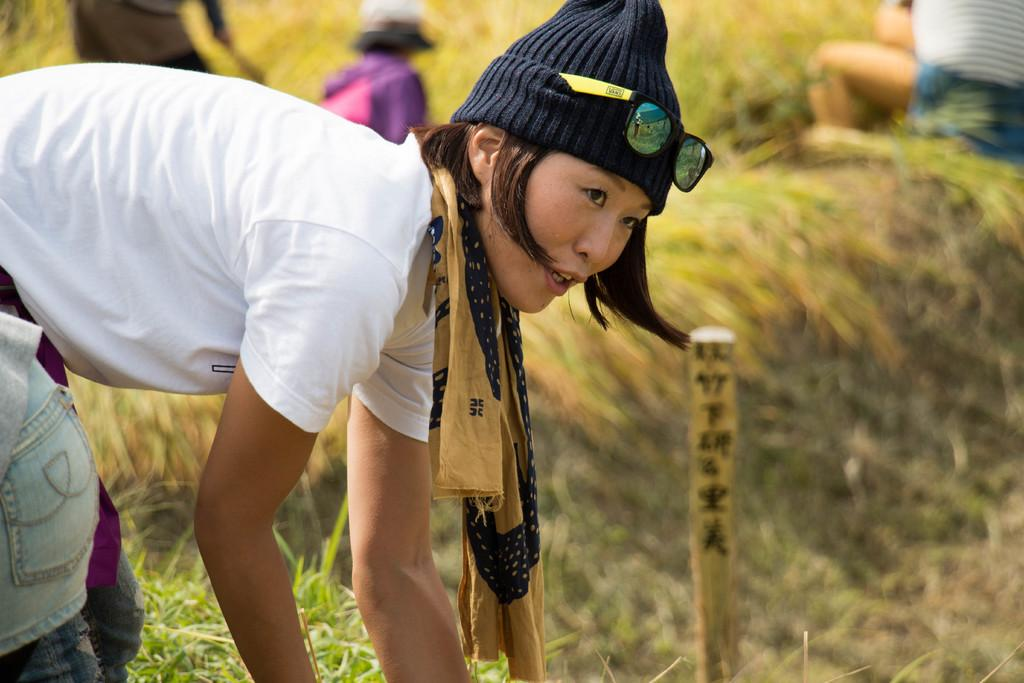What is the lady in the image wearing? The lady in the image is wearing a white top. What is the lady doing in the image? The lady is bending in the image. Are there any other people present in the image? Yes, there are other people in the image. What type of vegetation can be seen in the image? There are plants and grass in the image. What type of popcorn is being served to the laborer in the image? There is no laborer or popcorn present in the image. 